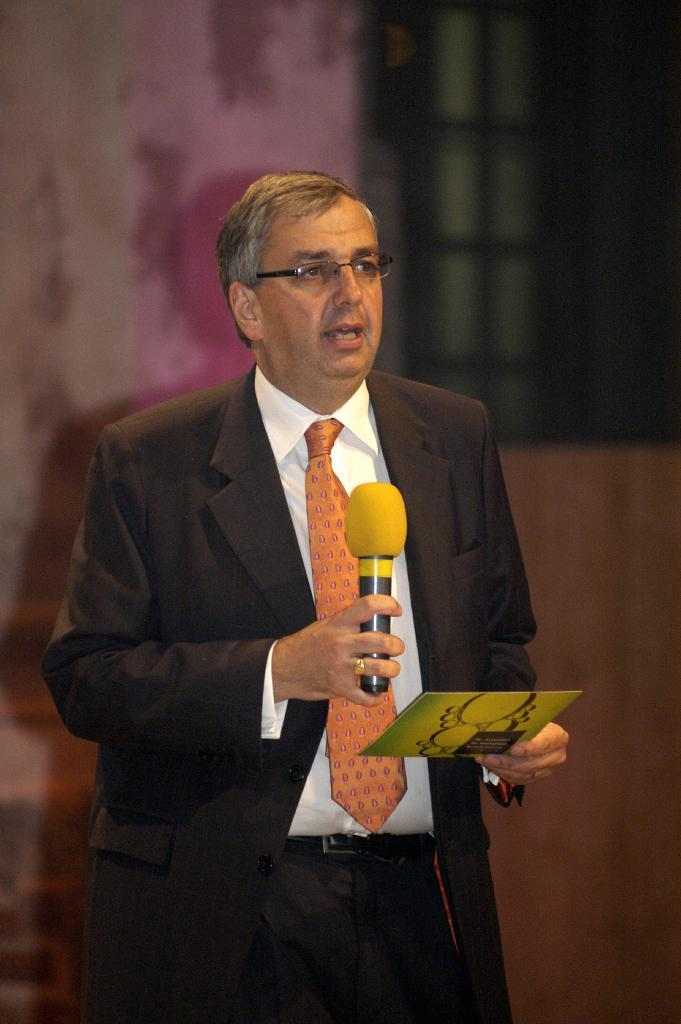What is the main subject of the image? The main subject of the image is a man. What is the man doing in the image? The man is standing, holding a microphone, and talking. What else is the man holding in his hand? The man is holding a card in his other hand. Can you describe the man's attire in the image? The man is wearing a blazer, a tie, and a shirt. How many trains can be seen in the image? There are no trains present in the image. 